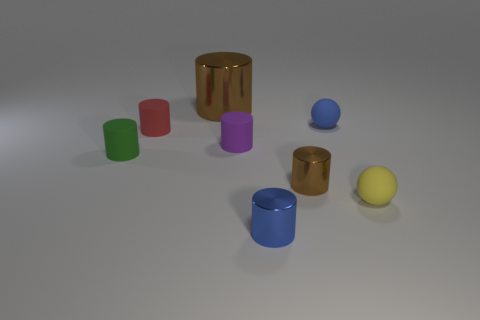What is the shape of the tiny object that is the same color as the large metallic object? The tiny object that shares its vivid blue color with the larger metallic cylinder is also a cylinder. It appears to be a miniature version of the larger one, featuring the same cylindrical shape characterized by its circular base and straight sides. 